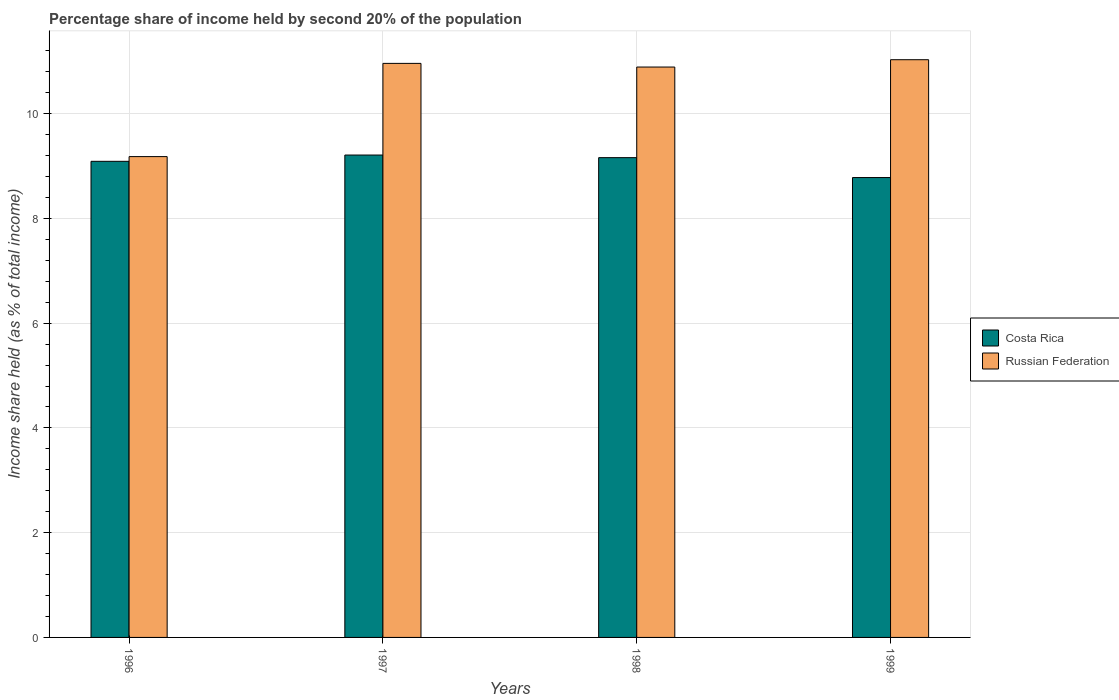How many groups of bars are there?
Give a very brief answer. 4. How many bars are there on the 2nd tick from the left?
Your response must be concise. 2. How many bars are there on the 3rd tick from the right?
Your answer should be very brief. 2. What is the label of the 1st group of bars from the left?
Give a very brief answer. 1996. In how many cases, is the number of bars for a given year not equal to the number of legend labels?
Provide a short and direct response. 0. What is the share of income held by second 20% of the population in Russian Federation in 1998?
Offer a terse response. 10.89. Across all years, what is the maximum share of income held by second 20% of the population in Costa Rica?
Offer a very short reply. 9.21. Across all years, what is the minimum share of income held by second 20% of the population in Russian Federation?
Provide a succinct answer. 9.18. What is the total share of income held by second 20% of the population in Russian Federation in the graph?
Offer a terse response. 42.06. What is the difference between the share of income held by second 20% of the population in Russian Federation in 1997 and that in 1998?
Your response must be concise. 0.07. What is the difference between the share of income held by second 20% of the population in Russian Federation in 1996 and the share of income held by second 20% of the population in Costa Rica in 1999?
Give a very brief answer. 0.4. What is the average share of income held by second 20% of the population in Russian Federation per year?
Provide a short and direct response. 10.52. In the year 1997, what is the difference between the share of income held by second 20% of the population in Russian Federation and share of income held by second 20% of the population in Costa Rica?
Offer a very short reply. 1.75. In how many years, is the share of income held by second 20% of the population in Russian Federation greater than 2.8 %?
Offer a terse response. 4. What is the ratio of the share of income held by second 20% of the population in Costa Rica in 1997 to that in 1998?
Offer a very short reply. 1.01. Is the share of income held by second 20% of the population in Russian Federation in 1998 less than that in 1999?
Give a very brief answer. Yes. Is the difference between the share of income held by second 20% of the population in Russian Federation in 1996 and 1999 greater than the difference between the share of income held by second 20% of the population in Costa Rica in 1996 and 1999?
Offer a terse response. No. What is the difference between the highest and the second highest share of income held by second 20% of the population in Costa Rica?
Provide a short and direct response. 0.05. What is the difference between the highest and the lowest share of income held by second 20% of the population in Russian Federation?
Offer a terse response. 1.85. Is the sum of the share of income held by second 20% of the population in Russian Federation in 1996 and 1997 greater than the maximum share of income held by second 20% of the population in Costa Rica across all years?
Offer a terse response. Yes. What does the 1st bar from the left in 1998 represents?
Offer a very short reply. Costa Rica. What does the 1st bar from the right in 1996 represents?
Give a very brief answer. Russian Federation. How many years are there in the graph?
Your answer should be very brief. 4. Are the values on the major ticks of Y-axis written in scientific E-notation?
Keep it short and to the point. No. Does the graph contain any zero values?
Give a very brief answer. No. How many legend labels are there?
Make the answer very short. 2. What is the title of the graph?
Give a very brief answer. Percentage share of income held by second 20% of the population. What is the label or title of the X-axis?
Provide a short and direct response. Years. What is the label or title of the Y-axis?
Your response must be concise. Income share held (as % of total income). What is the Income share held (as % of total income) of Costa Rica in 1996?
Ensure brevity in your answer.  9.09. What is the Income share held (as % of total income) of Russian Federation in 1996?
Give a very brief answer. 9.18. What is the Income share held (as % of total income) of Costa Rica in 1997?
Provide a succinct answer. 9.21. What is the Income share held (as % of total income) in Russian Federation in 1997?
Your answer should be very brief. 10.96. What is the Income share held (as % of total income) in Costa Rica in 1998?
Offer a very short reply. 9.16. What is the Income share held (as % of total income) in Russian Federation in 1998?
Provide a succinct answer. 10.89. What is the Income share held (as % of total income) of Costa Rica in 1999?
Make the answer very short. 8.78. What is the Income share held (as % of total income) of Russian Federation in 1999?
Your answer should be very brief. 11.03. Across all years, what is the maximum Income share held (as % of total income) of Costa Rica?
Offer a terse response. 9.21. Across all years, what is the maximum Income share held (as % of total income) of Russian Federation?
Offer a terse response. 11.03. Across all years, what is the minimum Income share held (as % of total income) in Costa Rica?
Ensure brevity in your answer.  8.78. Across all years, what is the minimum Income share held (as % of total income) of Russian Federation?
Offer a very short reply. 9.18. What is the total Income share held (as % of total income) of Costa Rica in the graph?
Offer a terse response. 36.24. What is the total Income share held (as % of total income) of Russian Federation in the graph?
Ensure brevity in your answer.  42.06. What is the difference between the Income share held (as % of total income) of Costa Rica in 1996 and that in 1997?
Provide a short and direct response. -0.12. What is the difference between the Income share held (as % of total income) of Russian Federation in 1996 and that in 1997?
Offer a very short reply. -1.78. What is the difference between the Income share held (as % of total income) in Costa Rica in 1996 and that in 1998?
Your answer should be very brief. -0.07. What is the difference between the Income share held (as % of total income) of Russian Federation in 1996 and that in 1998?
Your answer should be very brief. -1.71. What is the difference between the Income share held (as % of total income) of Costa Rica in 1996 and that in 1999?
Give a very brief answer. 0.31. What is the difference between the Income share held (as % of total income) in Russian Federation in 1996 and that in 1999?
Your response must be concise. -1.85. What is the difference between the Income share held (as % of total income) of Russian Federation in 1997 and that in 1998?
Make the answer very short. 0.07. What is the difference between the Income share held (as % of total income) of Costa Rica in 1997 and that in 1999?
Provide a short and direct response. 0.43. What is the difference between the Income share held (as % of total income) in Russian Federation in 1997 and that in 1999?
Provide a succinct answer. -0.07. What is the difference between the Income share held (as % of total income) in Costa Rica in 1998 and that in 1999?
Make the answer very short. 0.38. What is the difference between the Income share held (as % of total income) of Russian Federation in 1998 and that in 1999?
Give a very brief answer. -0.14. What is the difference between the Income share held (as % of total income) in Costa Rica in 1996 and the Income share held (as % of total income) in Russian Federation in 1997?
Ensure brevity in your answer.  -1.87. What is the difference between the Income share held (as % of total income) of Costa Rica in 1996 and the Income share held (as % of total income) of Russian Federation in 1999?
Keep it short and to the point. -1.94. What is the difference between the Income share held (as % of total income) in Costa Rica in 1997 and the Income share held (as % of total income) in Russian Federation in 1998?
Keep it short and to the point. -1.68. What is the difference between the Income share held (as % of total income) of Costa Rica in 1997 and the Income share held (as % of total income) of Russian Federation in 1999?
Offer a very short reply. -1.82. What is the difference between the Income share held (as % of total income) of Costa Rica in 1998 and the Income share held (as % of total income) of Russian Federation in 1999?
Your response must be concise. -1.87. What is the average Income share held (as % of total income) of Costa Rica per year?
Your answer should be compact. 9.06. What is the average Income share held (as % of total income) of Russian Federation per year?
Your answer should be very brief. 10.52. In the year 1996, what is the difference between the Income share held (as % of total income) in Costa Rica and Income share held (as % of total income) in Russian Federation?
Make the answer very short. -0.09. In the year 1997, what is the difference between the Income share held (as % of total income) of Costa Rica and Income share held (as % of total income) of Russian Federation?
Make the answer very short. -1.75. In the year 1998, what is the difference between the Income share held (as % of total income) in Costa Rica and Income share held (as % of total income) in Russian Federation?
Ensure brevity in your answer.  -1.73. In the year 1999, what is the difference between the Income share held (as % of total income) of Costa Rica and Income share held (as % of total income) of Russian Federation?
Your answer should be compact. -2.25. What is the ratio of the Income share held (as % of total income) in Costa Rica in 1996 to that in 1997?
Offer a very short reply. 0.99. What is the ratio of the Income share held (as % of total income) of Russian Federation in 1996 to that in 1997?
Offer a very short reply. 0.84. What is the ratio of the Income share held (as % of total income) of Costa Rica in 1996 to that in 1998?
Give a very brief answer. 0.99. What is the ratio of the Income share held (as % of total income) in Russian Federation in 1996 to that in 1998?
Keep it short and to the point. 0.84. What is the ratio of the Income share held (as % of total income) in Costa Rica in 1996 to that in 1999?
Your answer should be compact. 1.04. What is the ratio of the Income share held (as % of total income) of Russian Federation in 1996 to that in 1999?
Your answer should be very brief. 0.83. What is the ratio of the Income share held (as % of total income) in Costa Rica in 1997 to that in 1998?
Provide a succinct answer. 1.01. What is the ratio of the Income share held (as % of total income) of Russian Federation in 1997 to that in 1998?
Your response must be concise. 1.01. What is the ratio of the Income share held (as % of total income) in Costa Rica in 1997 to that in 1999?
Your answer should be very brief. 1.05. What is the ratio of the Income share held (as % of total income) in Costa Rica in 1998 to that in 1999?
Your answer should be very brief. 1.04. What is the ratio of the Income share held (as % of total income) of Russian Federation in 1998 to that in 1999?
Provide a short and direct response. 0.99. What is the difference between the highest and the second highest Income share held (as % of total income) in Russian Federation?
Keep it short and to the point. 0.07. What is the difference between the highest and the lowest Income share held (as % of total income) of Costa Rica?
Offer a very short reply. 0.43. What is the difference between the highest and the lowest Income share held (as % of total income) of Russian Federation?
Your answer should be compact. 1.85. 